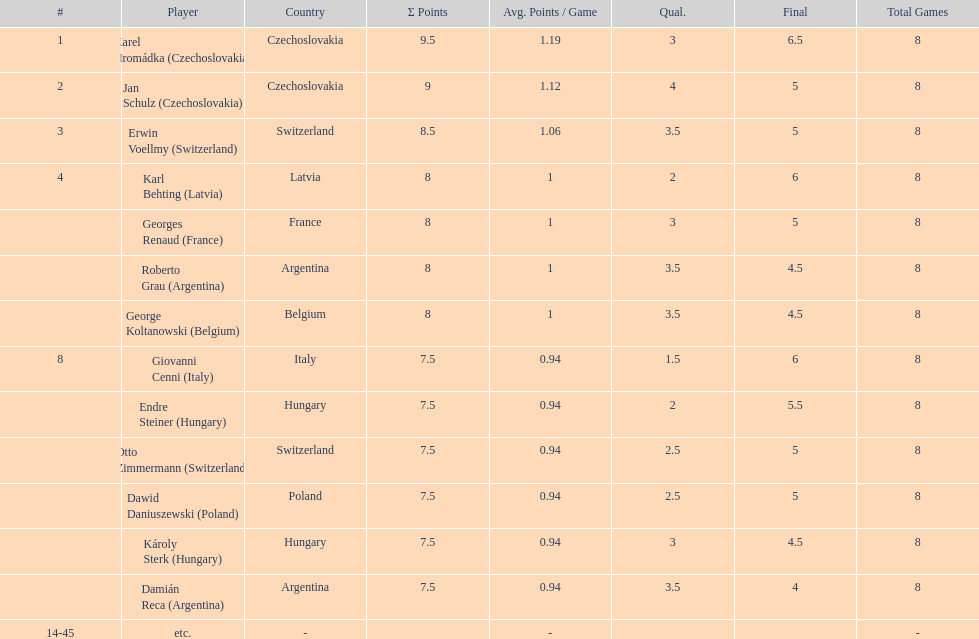How many countries had more than one player in the consolation cup? 4. 